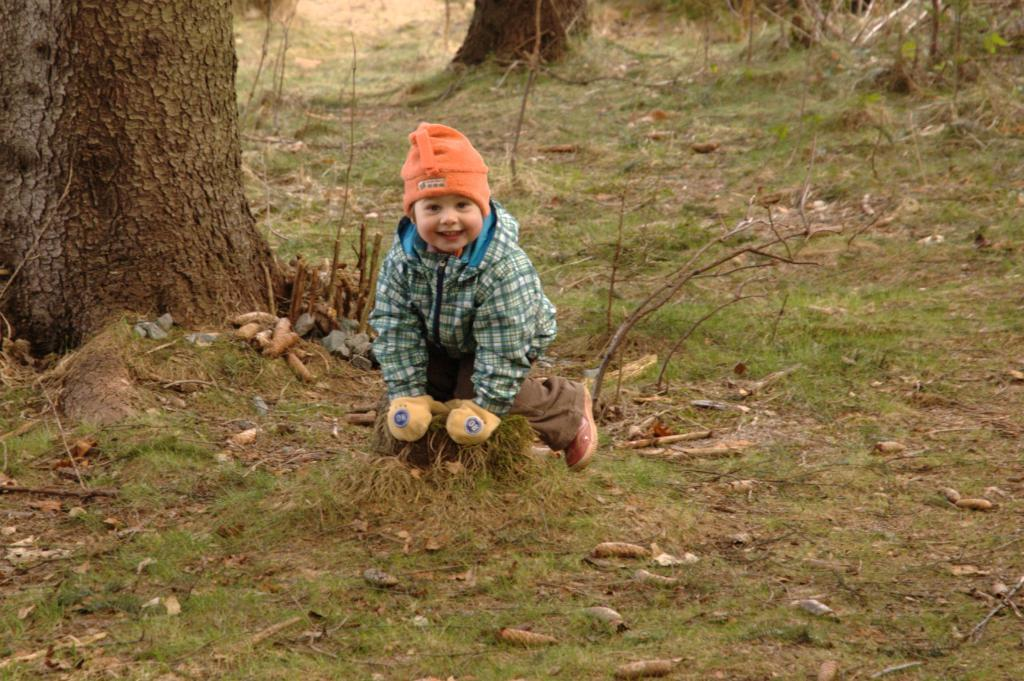What is the main subject in the center of the image? There is a boy in the center of the image. What is the boy wearing on his head? The boy is wearing a hat. What is the boy wearing on his hands? The boy is wearing gloves. What type of terrain is visible at the bottom of the image? There is grass at the bottom of the image, and some scrap is also present. What can be seen in the background of the image? There are trees in the background of the image. What type of beef is being cooked on the grill in the image? There is no grill or beef present in the image; it features a boy wearing a hat and gloves, with grass and trees in the background. 